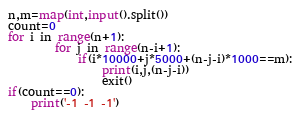<code> <loc_0><loc_0><loc_500><loc_500><_Python_>n,m=map(int,input().split())
count=0
for i in range(n+1):
		for j in range(n-i+1):
			if(i*10000+j*5000+(n-j-i)*1000==m):
				print(i,j,(n-j-i))
				exit()
if(count==0):
	print('-1 -1 -1')</code> 